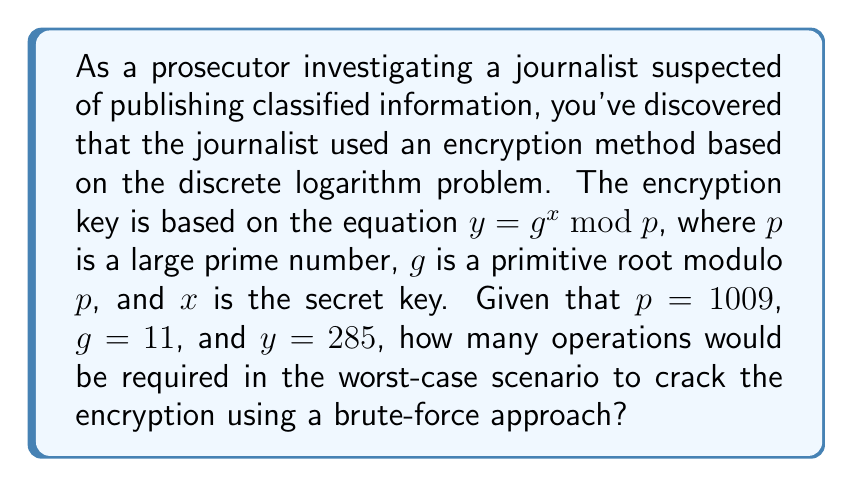What is the answer to this math problem? To solve this problem, we need to understand the discrete logarithm problem and how it relates to encryption strength. The equation $y = g^x \mod p$ is the basis of many cryptographic systems, where finding $x$ given $y$, $g$, and $p$ is computationally difficult for large values of $p$.

1) In a brute-force approach, we would need to try all possible values of $x$ until we find the one that satisfies the equation.

2) The range of possible values for $x$ is from 1 to $p-1$, as the discrete logarithm is defined in the multiplicative group of integers modulo $p$.

3) Therefore, in the worst-case scenario, we would need to perform $p-1$ operations.

4) In this case, $p = 1009$, so the maximum number of operations would be:

   $$1009 - 1 = 1008$$

5) Each operation involves computing $g^x \mod p$ and comparing it to $y$, which itself requires multiple arithmetic operations. However, for the purposes of this analysis, we consider each try as one operation.

This demonstrates why larger primes are used in practical cryptography, as they exponentially increase the number of possible operations required for a brute-force attack.
Answer: 1008 operations 